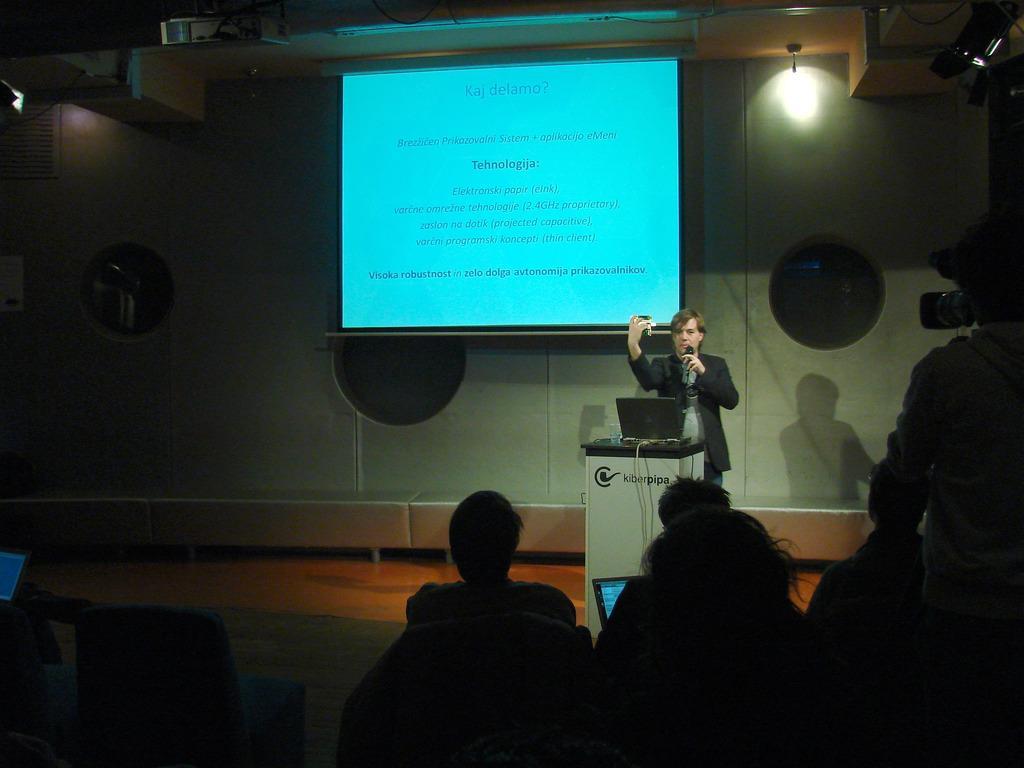How would you summarize this image in a sentence or two? In this picture we can see a man wearing black suit, standing at the speech desk and giving a speech. Behind there is a projector screen and white panel wall. In the front there are some people standing and listening to him. 